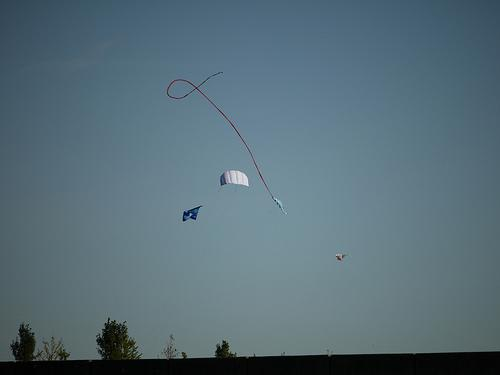Question: why are the objects in the sky?
Choices:
A. Thrown.
B. Tossed.
C. Flying.
D. Escaping.
Answer with the letter. Answer: C Question: where are the trees?
Choices:
A. On land.
B. In chopper.
C. On mountain.
D. Around pond.
Answer with the letter. Answer: A Question: what color is the sky?
Choices:
A. Grey.
B. Blue.
C. White.
D. Black.
Answer with the letter. Answer: B 